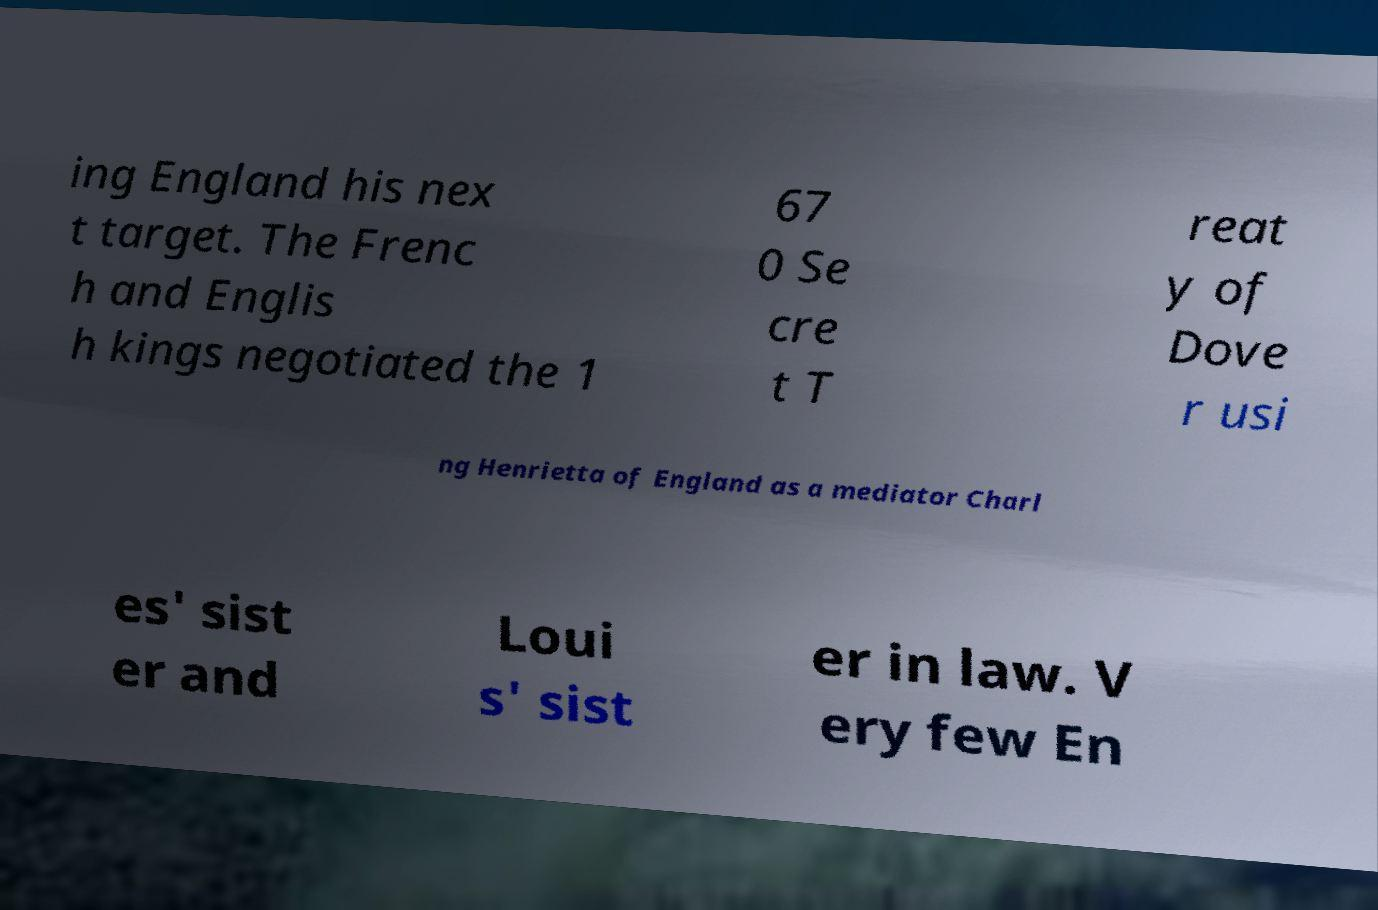Could you assist in decoding the text presented in this image and type it out clearly? ing England his nex t target. The Frenc h and Englis h kings negotiated the 1 67 0 Se cre t T reat y of Dove r usi ng Henrietta of England as a mediator Charl es' sist er and Loui s' sist er in law. V ery few En 